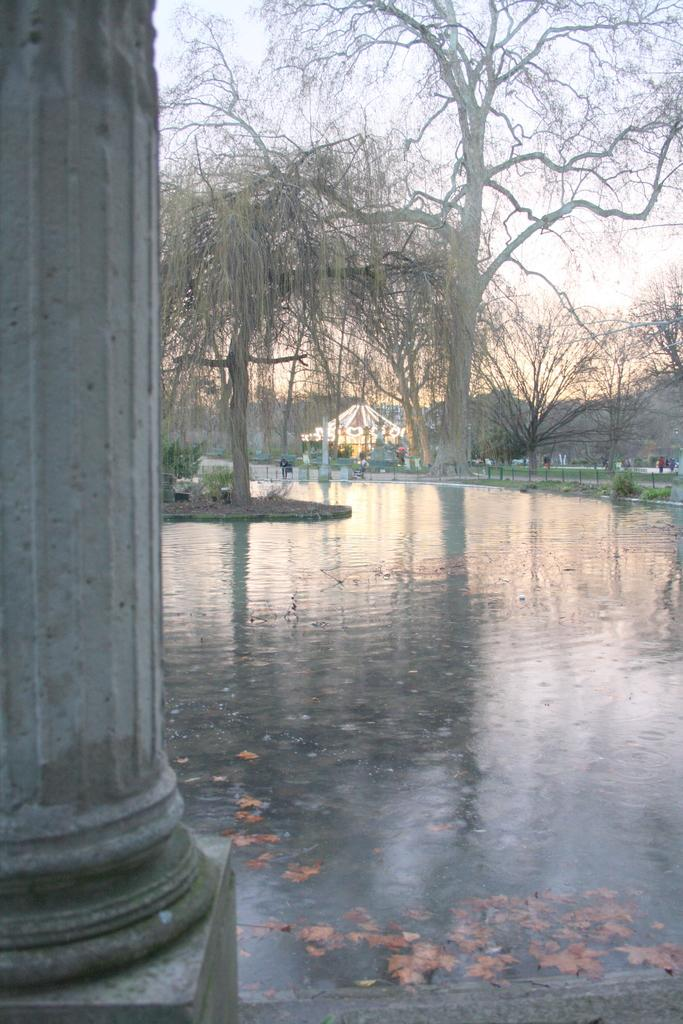What is the main structure in the image? There is a pillar in the image. What color is the pillar? The pillar is white. What can be seen in the background of the image? There are trees and water visible in the background of the image. What is the color of the trees? The trees are green. What is the color of the sky in the image? The sky is white in the image. How many houses are visible in the image? There are no houses visible in the image; it features a white pillar, green trees, water, and a white sky. What type of sun can be seen in the image? There is no sun visible in the image. 